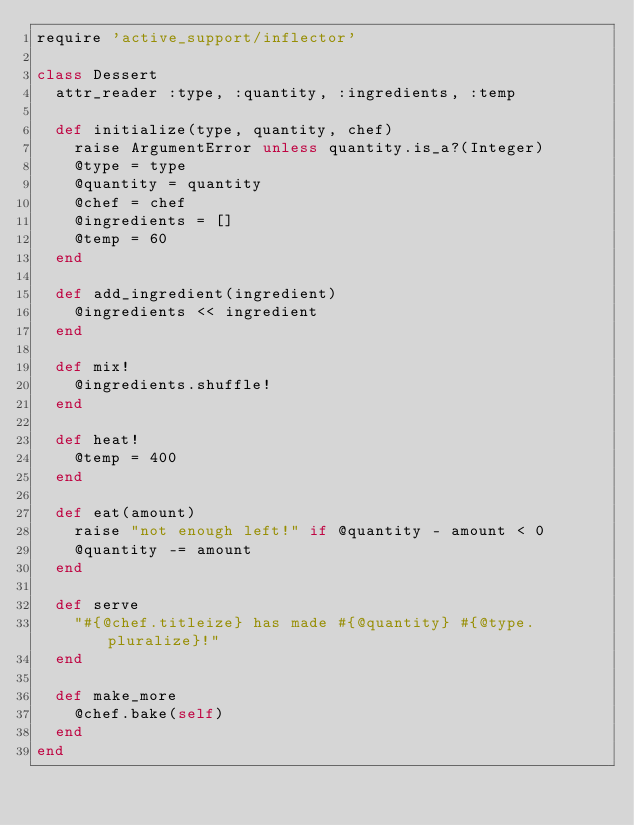Convert code to text. <code><loc_0><loc_0><loc_500><loc_500><_Ruby_>require 'active_support/inflector'

class Dessert
  attr_reader :type, :quantity, :ingredients, :temp

  def initialize(type, quantity, chef)
    raise ArgumentError unless quantity.is_a?(Integer)
    @type = type
    @quantity = quantity
    @chef = chef
    @ingredients = []
    @temp = 60
  end

  def add_ingredient(ingredient)
    @ingredients << ingredient
  end

  def mix!
    @ingredients.shuffle!
  end

  def heat!
    @temp = 400
  end

  def eat(amount)
    raise "not enough left!" if @quantity - amount < 0
    @quantity -= amount
  end

  def serve
    "#{@chef.titleize} has made #{@quantity} #{@type.pluralize}!"
  end

  def make_more
    @chef.bake(self)
  end
end
</code> 